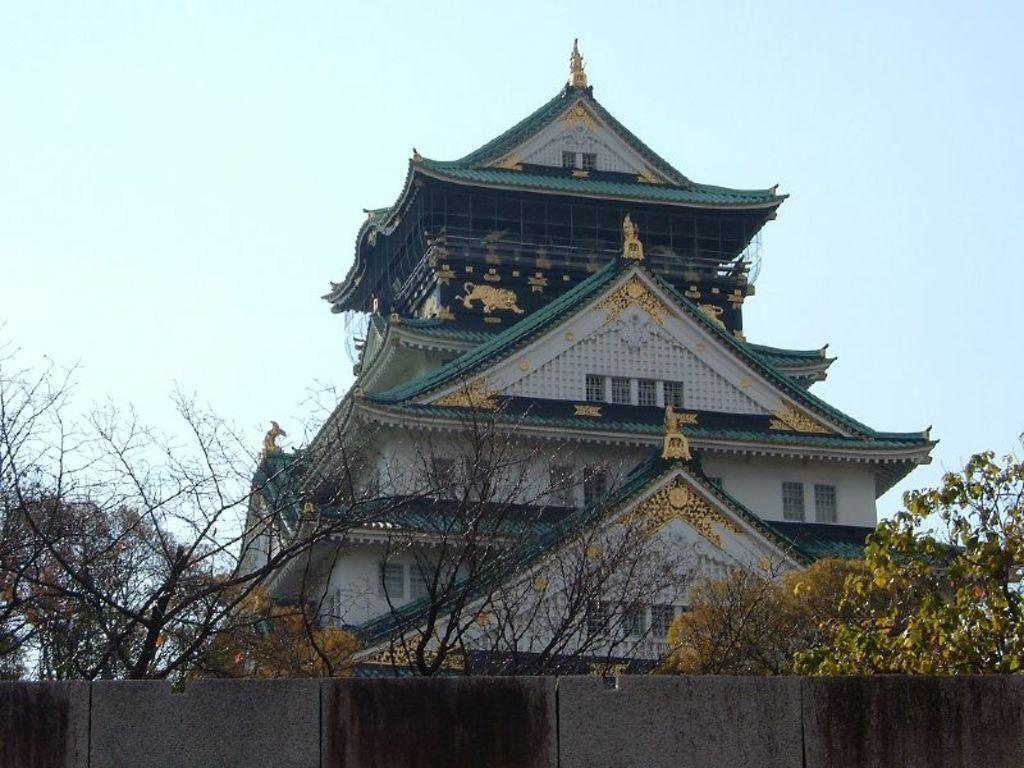What is the main structure in the middle of the image? There is a house in the middle of the image. What type of vegetation is present at the bottom of the image? There are trees at the bottom of the image. What is visible at the top of the image? The sky is visible at the top of the image. How much debt is the house in the image carrying? There is no information about the house's debt in the image, as it is not relevant to the visual content. 